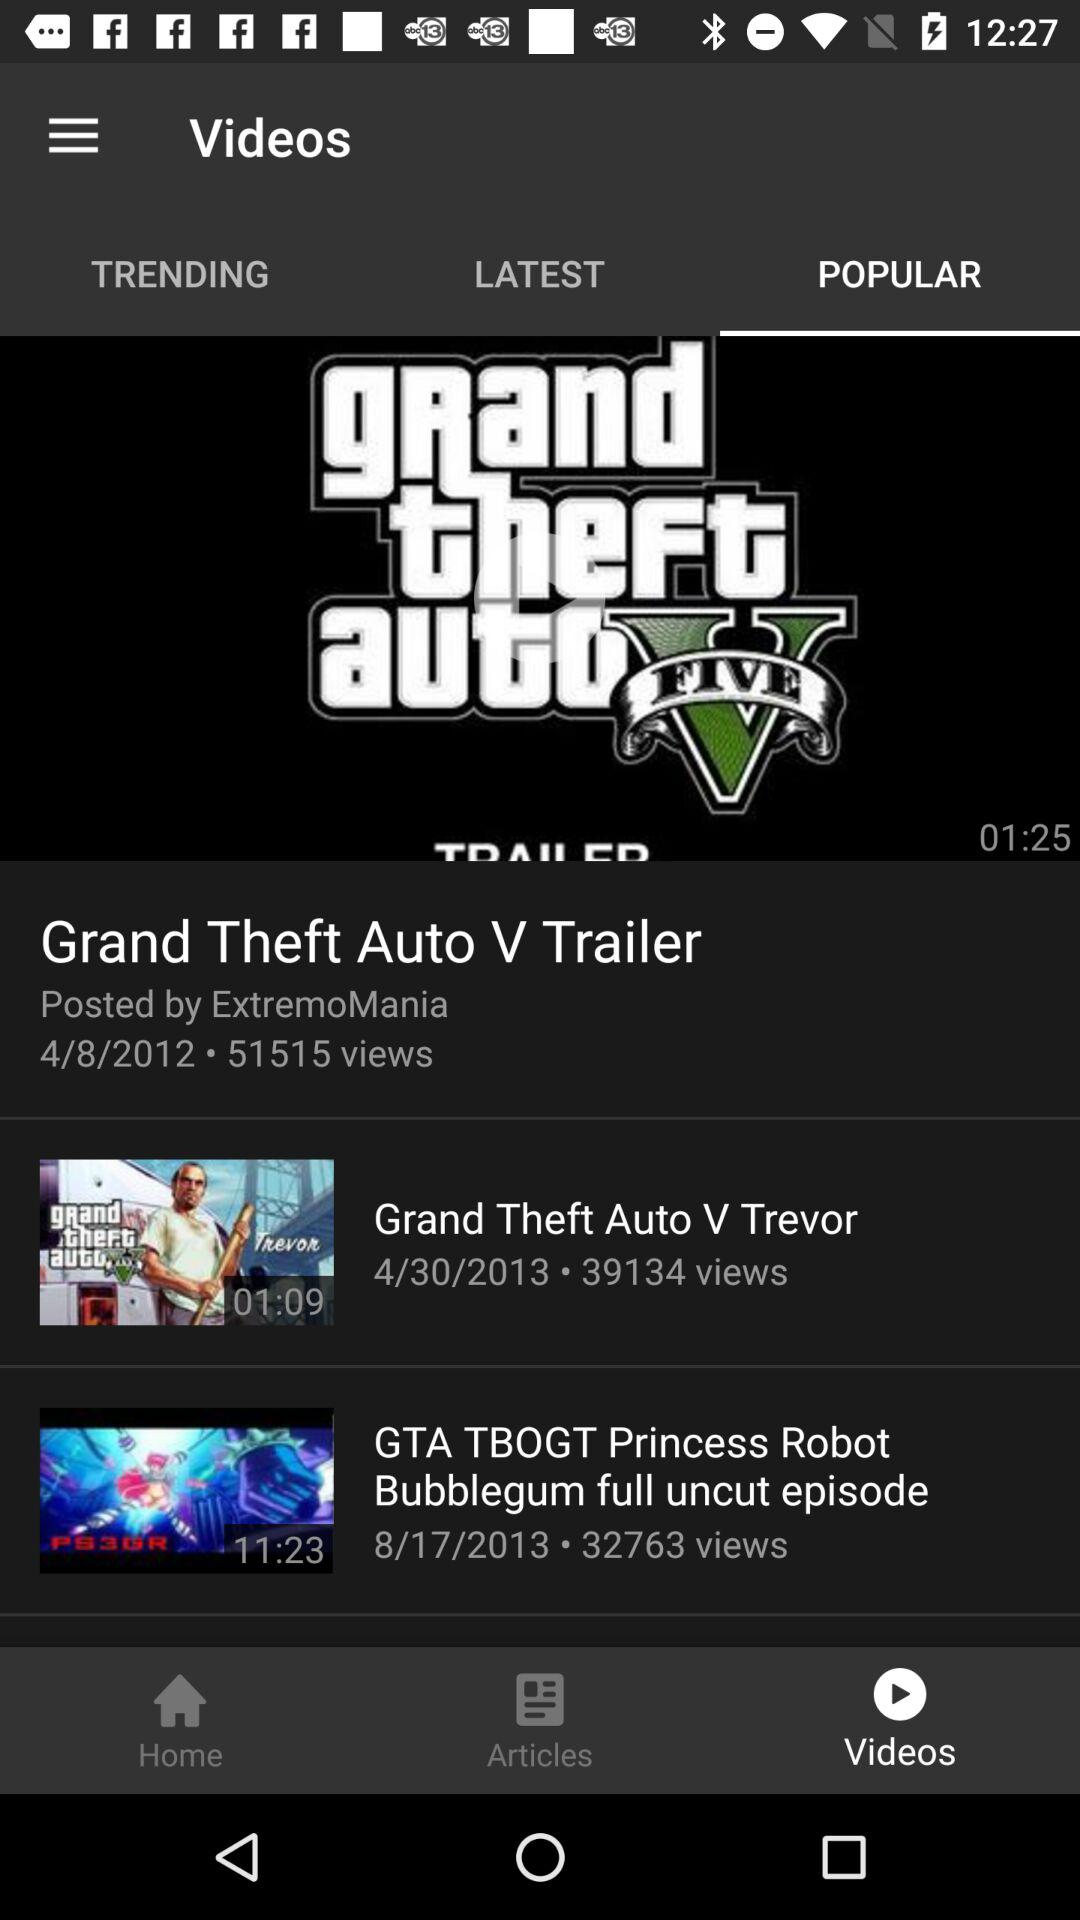What is the date? The dates are April 8, 2012; April 30, 2013 and August 17, 2013. 